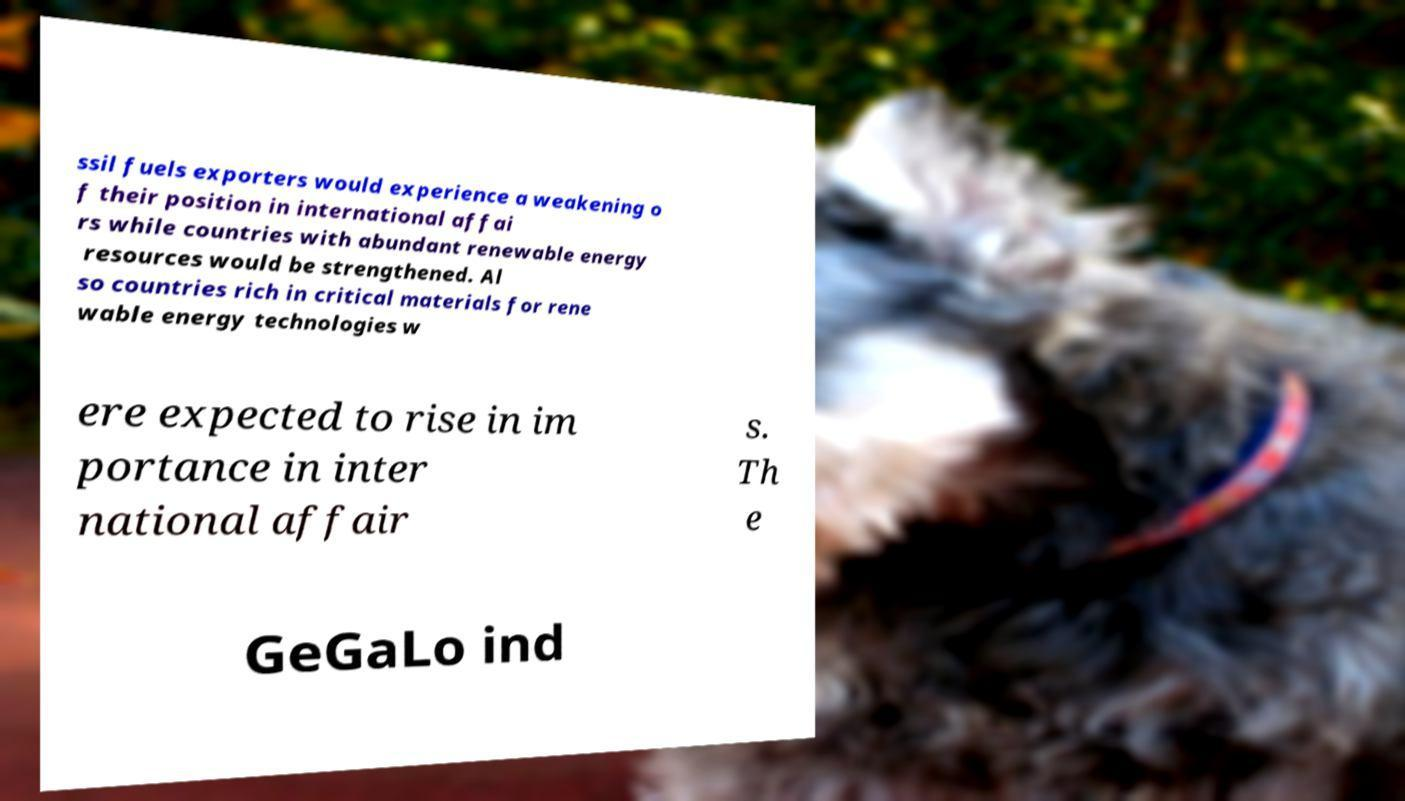For documentation purposes, I need the text within this image transcribed. Could you provide that? ssil fuels exporters would experience a weakening o f their position in international affai rs while countries with abundant renewable energy resources would be strengthened. Al so countries rich in critical materials for rene wable energy technologies w ere expected to rise in im portance in inter national affair s. Th e GeGaLo ind 